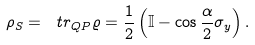Convert formula to latex. <formula><loc_0><loc_0><loc_500><loc_500>\rho _ { S } = \ t r _ { Q P } \varrho = \frac { 1 } { 2 } \left ( \mathbb { I } - \cos \frac { \alpha } { 2 } \sigma _ { y } \right ) .</formula> 